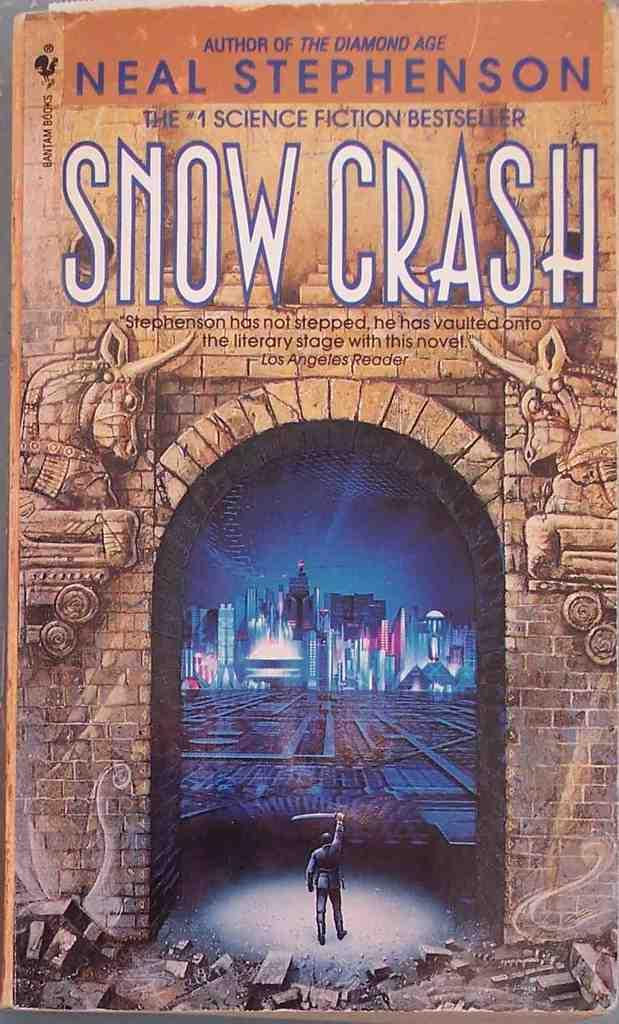<image>
Write a terse but informative summary of the picture. The cover of Neal Stephenson's book Snow Crash. 